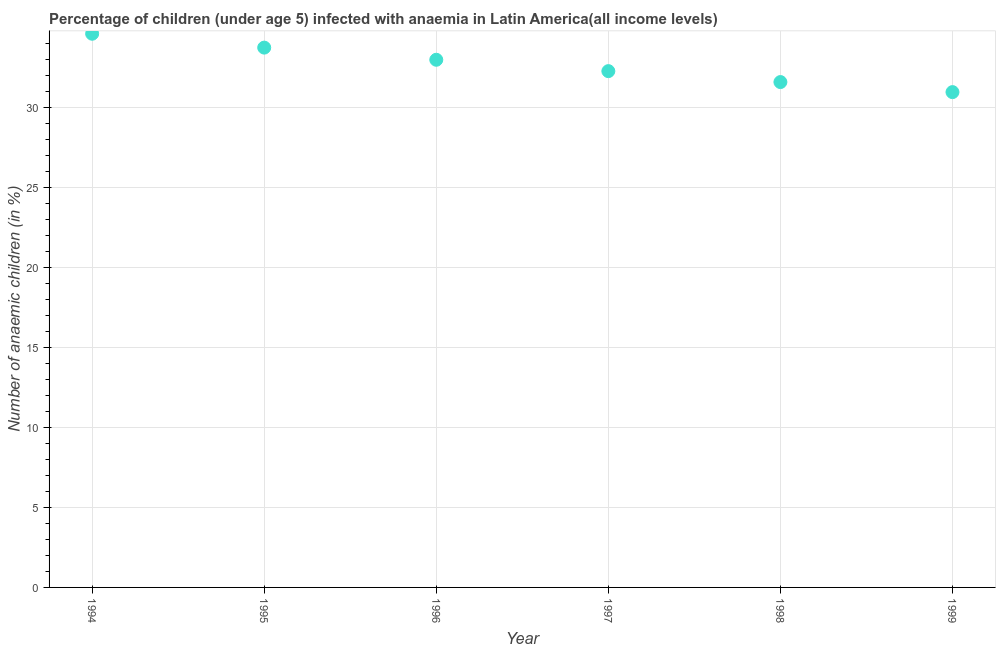What is the number of anaemic children in 1996?
Ensure brevity in your answer.  32.98. Across all years, what is the maximum number of anaemic children?
Your answer should be very brief. 34.6. Across all years, what is the minimum number of anaemic children?
Your answer should be very brief. 30.95. In which year was the number of anaemic children maximum?
Offer a terse response. 1994. What is the sum of the number of anaemic children?
Your answer should be very brief. 196.12. What is the difference between the number of anaemic children in 1996 and 1997?
Give a very brief answer. 0.71. What is the average number of anaemic children per year?
Give a very brief answer. 32.69. What is the median number of anaemic children?
Your response must be concise. 32.62. What is the ratio of the number of anaemic children in 1997 to that in 1998?
Provide a succinct answer. 1.02. Is the difference between the number of anaemic children in 1997 and 1999 greater than the difference between any two years?
Provide a succinct answer. No. What is the difference between the highest and the second highest number of anaemic children?
Give a very brief answer. 0.87. Is the sum of the number of anaemic children in 1995 and 1996 greater than the maximum number of anaemic children across all years?
Ensure brevity in your answer.  Yes. What is the difference between the highest and the lowest number of anaemic children?
Provide a short and direct response. 3.65. In how many years, is the number of anaemic children greater than the average number of anaemic children taken over all years?
Ensure brevity in your answer.  3. Are the values on the major ticks of Y-axis written in scientific E-notation?
Offer a very short reply. No. Does the graph contain grids?
Make the answer very short. Yes. What is the title of the graph?
Your answer should be very brief. Percentage of children (under age 5) infected with anaemia in Latin America(all income levels). What is the label or title of the Y-axis?
Make the answer very short. Number of anaemic children (in %). What is the Number of anaemic children (in %) in 1994?
Provide a succinct answer. 34.6. What is the Number of anaemic children (in %) in 1995?
Your answer should be very brief. 33.74. What is the Number of anaemic children (in %) in 1996?
Keep it short and to the point. 32.98. What is the Number of anaemic children (in %) in 1997?
Offer a terse response. 32.27. What is the Number of anaemic children (in %) in 1998?
Offer a very short reply. 31.58. What is the Number of anaemic children (in %) in 1999?
Offer a very short reply. 30.95. What is the difference between the Number of anaemic children (in %) in 1994 and 1995?
Ensure brevity in your answer.  0.87. What is the difference between the Number of anaemic children (in %) in 1994 and 1996?
Give a very brief answer. 1.63. What is the difference between the Number of anaemic children (in %) in 1994 and 1997?
Keep it short and to the point. 2.34. What is the difference between the Number of anaemic children (in %) in 1994 and 1998?
Ensure brevity in your answer.  3.02. What is the difference between the Number of anaemic children (in %) in 1994 and 1999?
Ensure brevity in your answer.  3.65. What is the difference between the Number of anaemic children (in %) in 1995 and 1996?
Your answer should be compact. 0.76. What is the difference between the Number of anaemic children (in %) in 1995 and 1997?
Provide a short and direct response. 1.47. What is the difference between the Number of anaemic children (in %) in 1995 and 1998?
Offer a terse response. 2.15. What is the difference between the Number of anaemic children (in %) in 1995 and 1999?
Ensure brevity in your answer.  2.78. What is the difference between the Number of anaemic children (in %) in 1996 and 1997?
Make the answer very short. 0.71. What is the difference between the Number of anaemic children (in %) in 1996 and 1998?
Ensure brevity in your answer.  1.39. What is the difference between the Number of anaemic children (in %) in 1996 and 1999?
Give a very brief answer. 2.02. What is the difference between the Number of anaemic children (in %) in 1997 and 1998?
Ensure brevity in your answer.  0.68. What is the difference between the Number of anaemic children (in %) in 1997 and 1999?
Ensure brevity in your answer.  1.31. What is the difference between the Number of anaemic children (in %) in 1998 and 1999?
Give a very brief answer. 0.63. What is the ratio of the Number of anaemic children (in %) in 1994 to that in 1996?
Provide a short and direct response. 1.05. What is the ratio of the Number of anaemic children (in %) in 1994 to that in 1997?
Ensure brevity in your answer.  1.07. What is the ratio of the Number of anaemic children (in %) in 1994 to that in 1998?
Offer a terse response. 1.1. What is the ratio of the Number of anaemic children (in %) in 1994 to that in 1999?
Ensure brevity in your answer.  1.12. What is the ratio of the Number of anaemic children (in %) in 1995 to that in 1997?
Your response must be concise. 1.05. What is the ratio of the Number of anaemic children (in %) in 1995 to that in 1998?
Offer a terse response. 1.07. What is the ratio of the Number of anaemic children (in %) in 1995 to that in 1999?
Give a very brief answer. 1.09. What is the ratio of the Number of anaemic children (in %) in 1996 to that in 1998?
Your response must be concise. 1.04. What is the ratio of the Number of anaemic children (in %) in 1996 to that in 1999?
Your answer should be very brief. 1.06. What is the ratio of the Number of anaemic children (in %) in 1997 to that in 1999?
Provide a succinct answer. 1.04. What is the ratio of the Number of anaemic children (in %) in 1998 to that in 1999?
Provide a succinct answer. 1.02. 